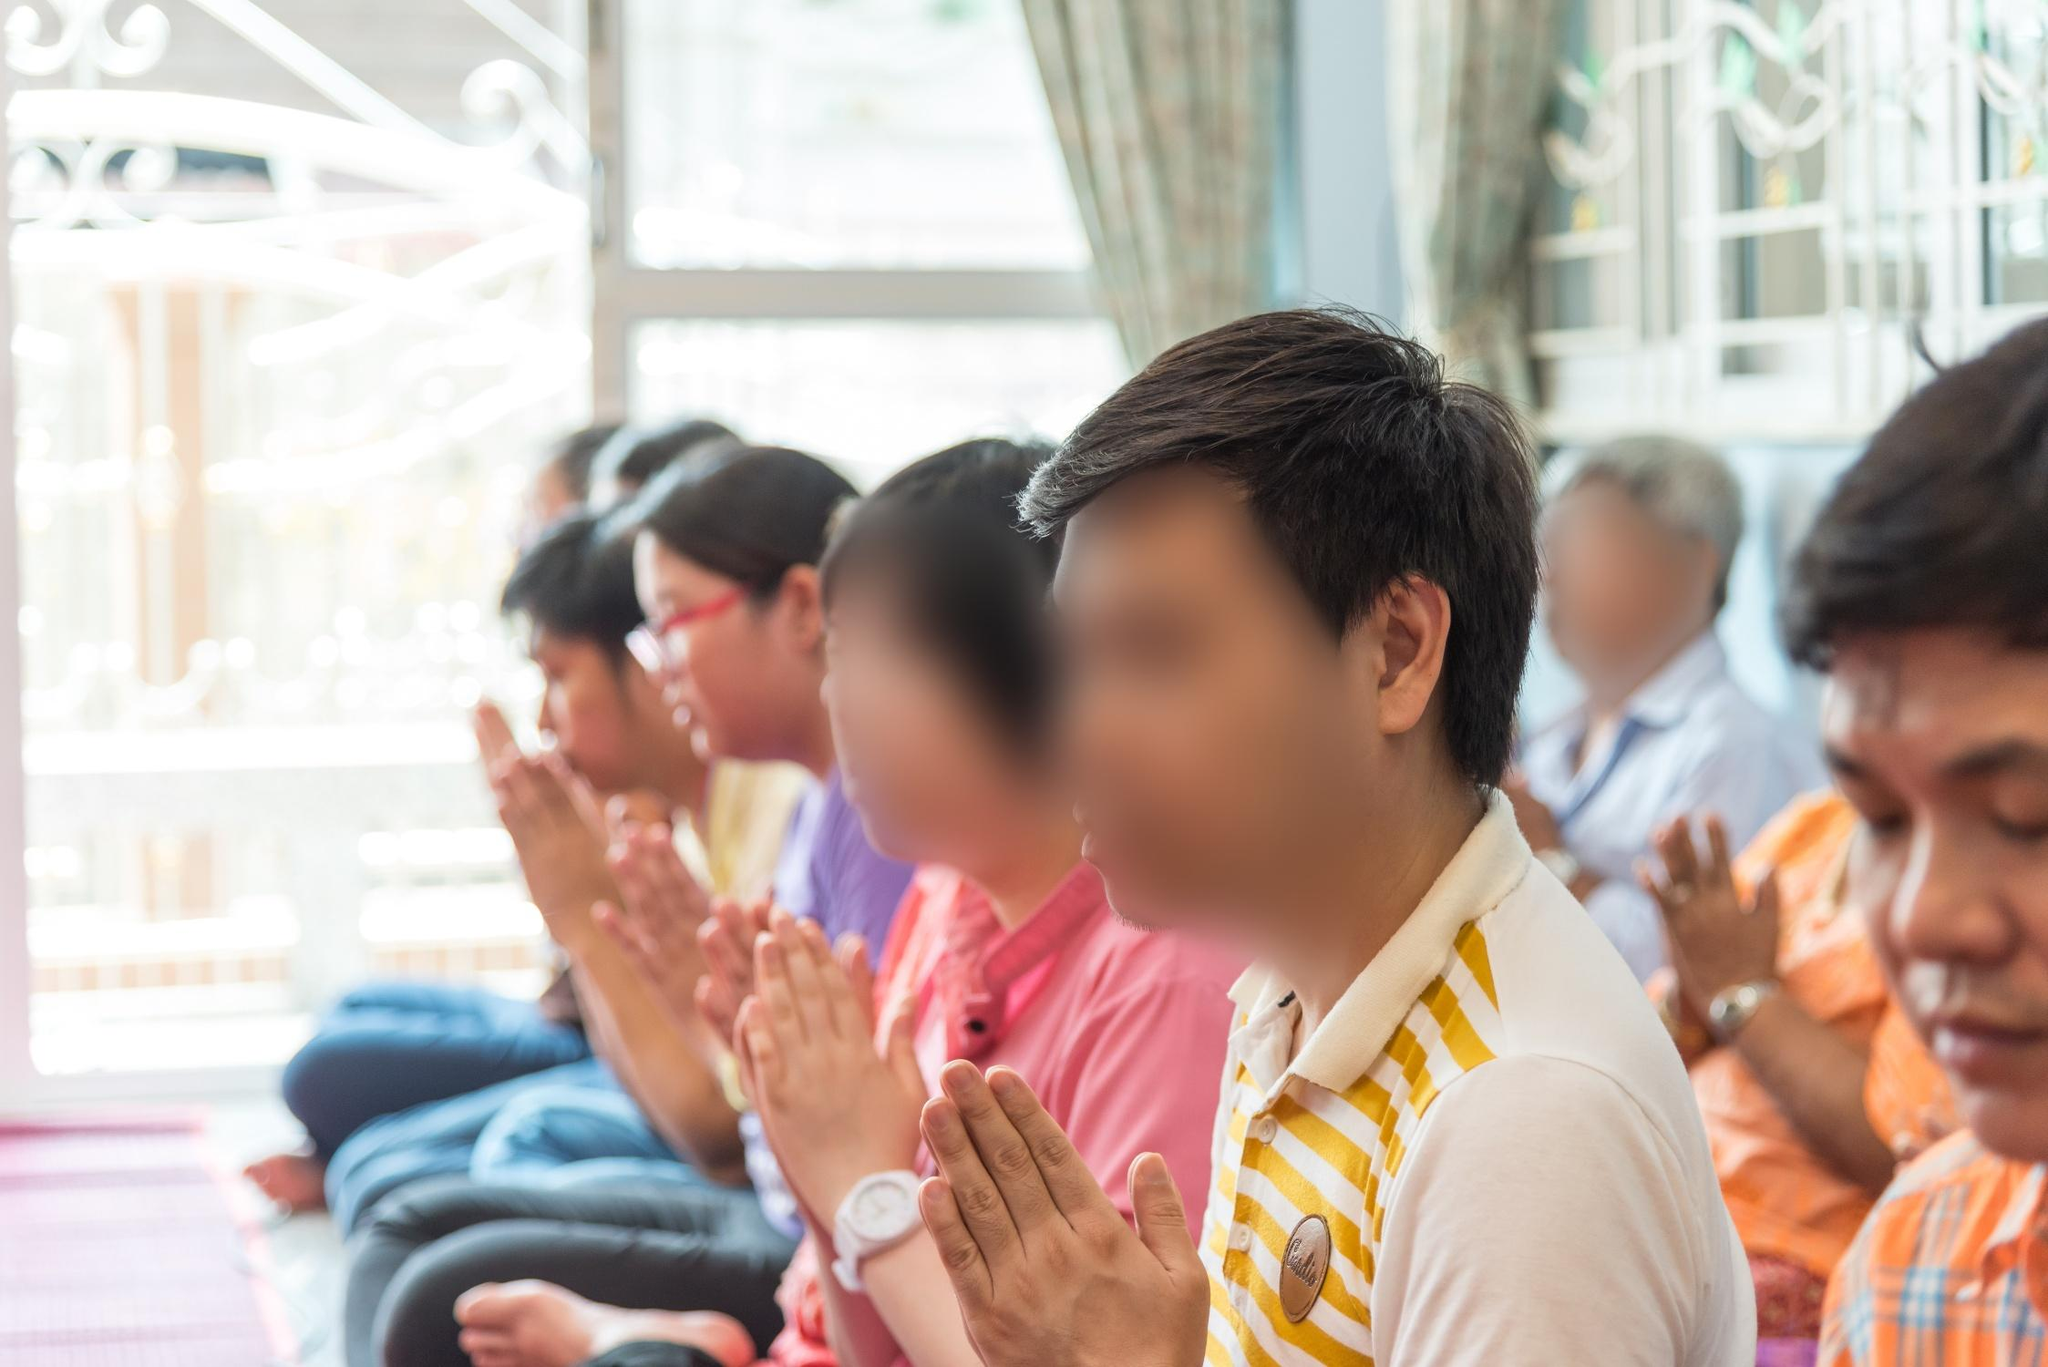What do you think is going on in this snapshot? The image portrays a group of individuals engaged in prayer within a serene and sacred temple setting. They are seated on the floor, dressed in vibrant and varied attire, with their hands clasped together in a gesture of devoutness. The individual in the foreground is prominently focused, their expression serene and peaceful, symbolizing a deep state of spiritual reflection. The shallow depth of field sharpens the subjects in focus while the soft blur in the background accentuates the intimacy of the moment. A window adorned with curtains partially frames the scene, providing a subtle glimpse into the temple's exterior ambience. This visual composition collectively conveys a moment of tranquil devotion and a shared spiritual connection among the participants. 